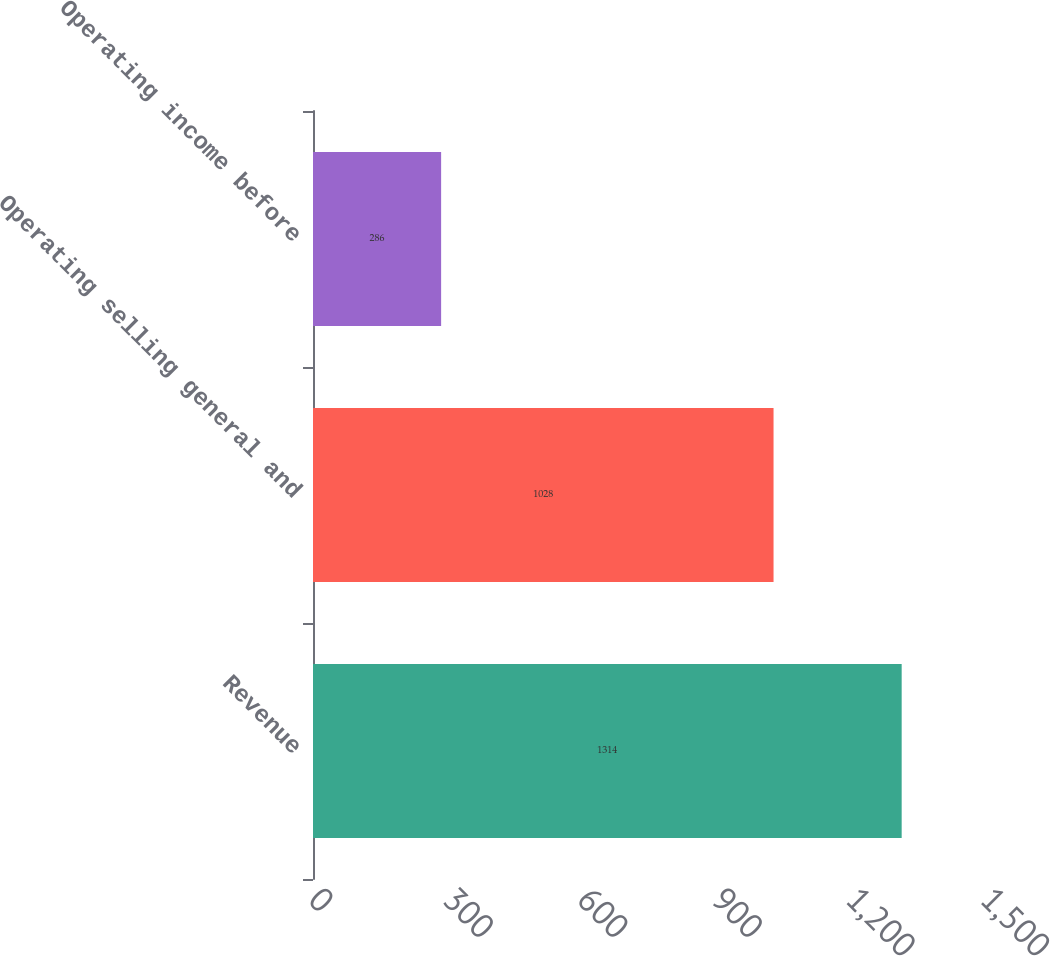<chart> <loc_0><loc_0><loc_500><loc_500><bar_chart><fcel>Revenue<fcel>Operating selling general and<fcel>Operating income before<nl><fcel>1314<fcel>1028<fcel>286<nl></chart> 